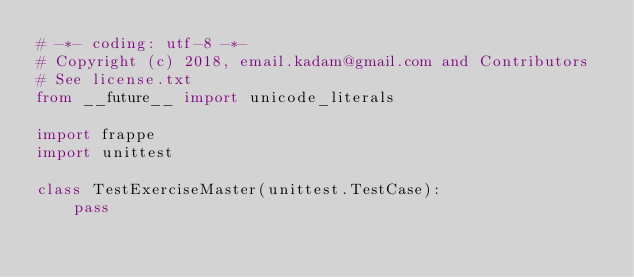<code> <loc_0><loc_0><loc_500><loc_500><_Python_># -*- coding: utf-8 -*-
# Copyright (c) 2018, email.kadam@gmail.com and Contributors
# See license.txt
from __future__ import unicode_literals

import frappe
import unittest

class TestExerciseMaster(unittest.TestCase):
	pass
</code> 